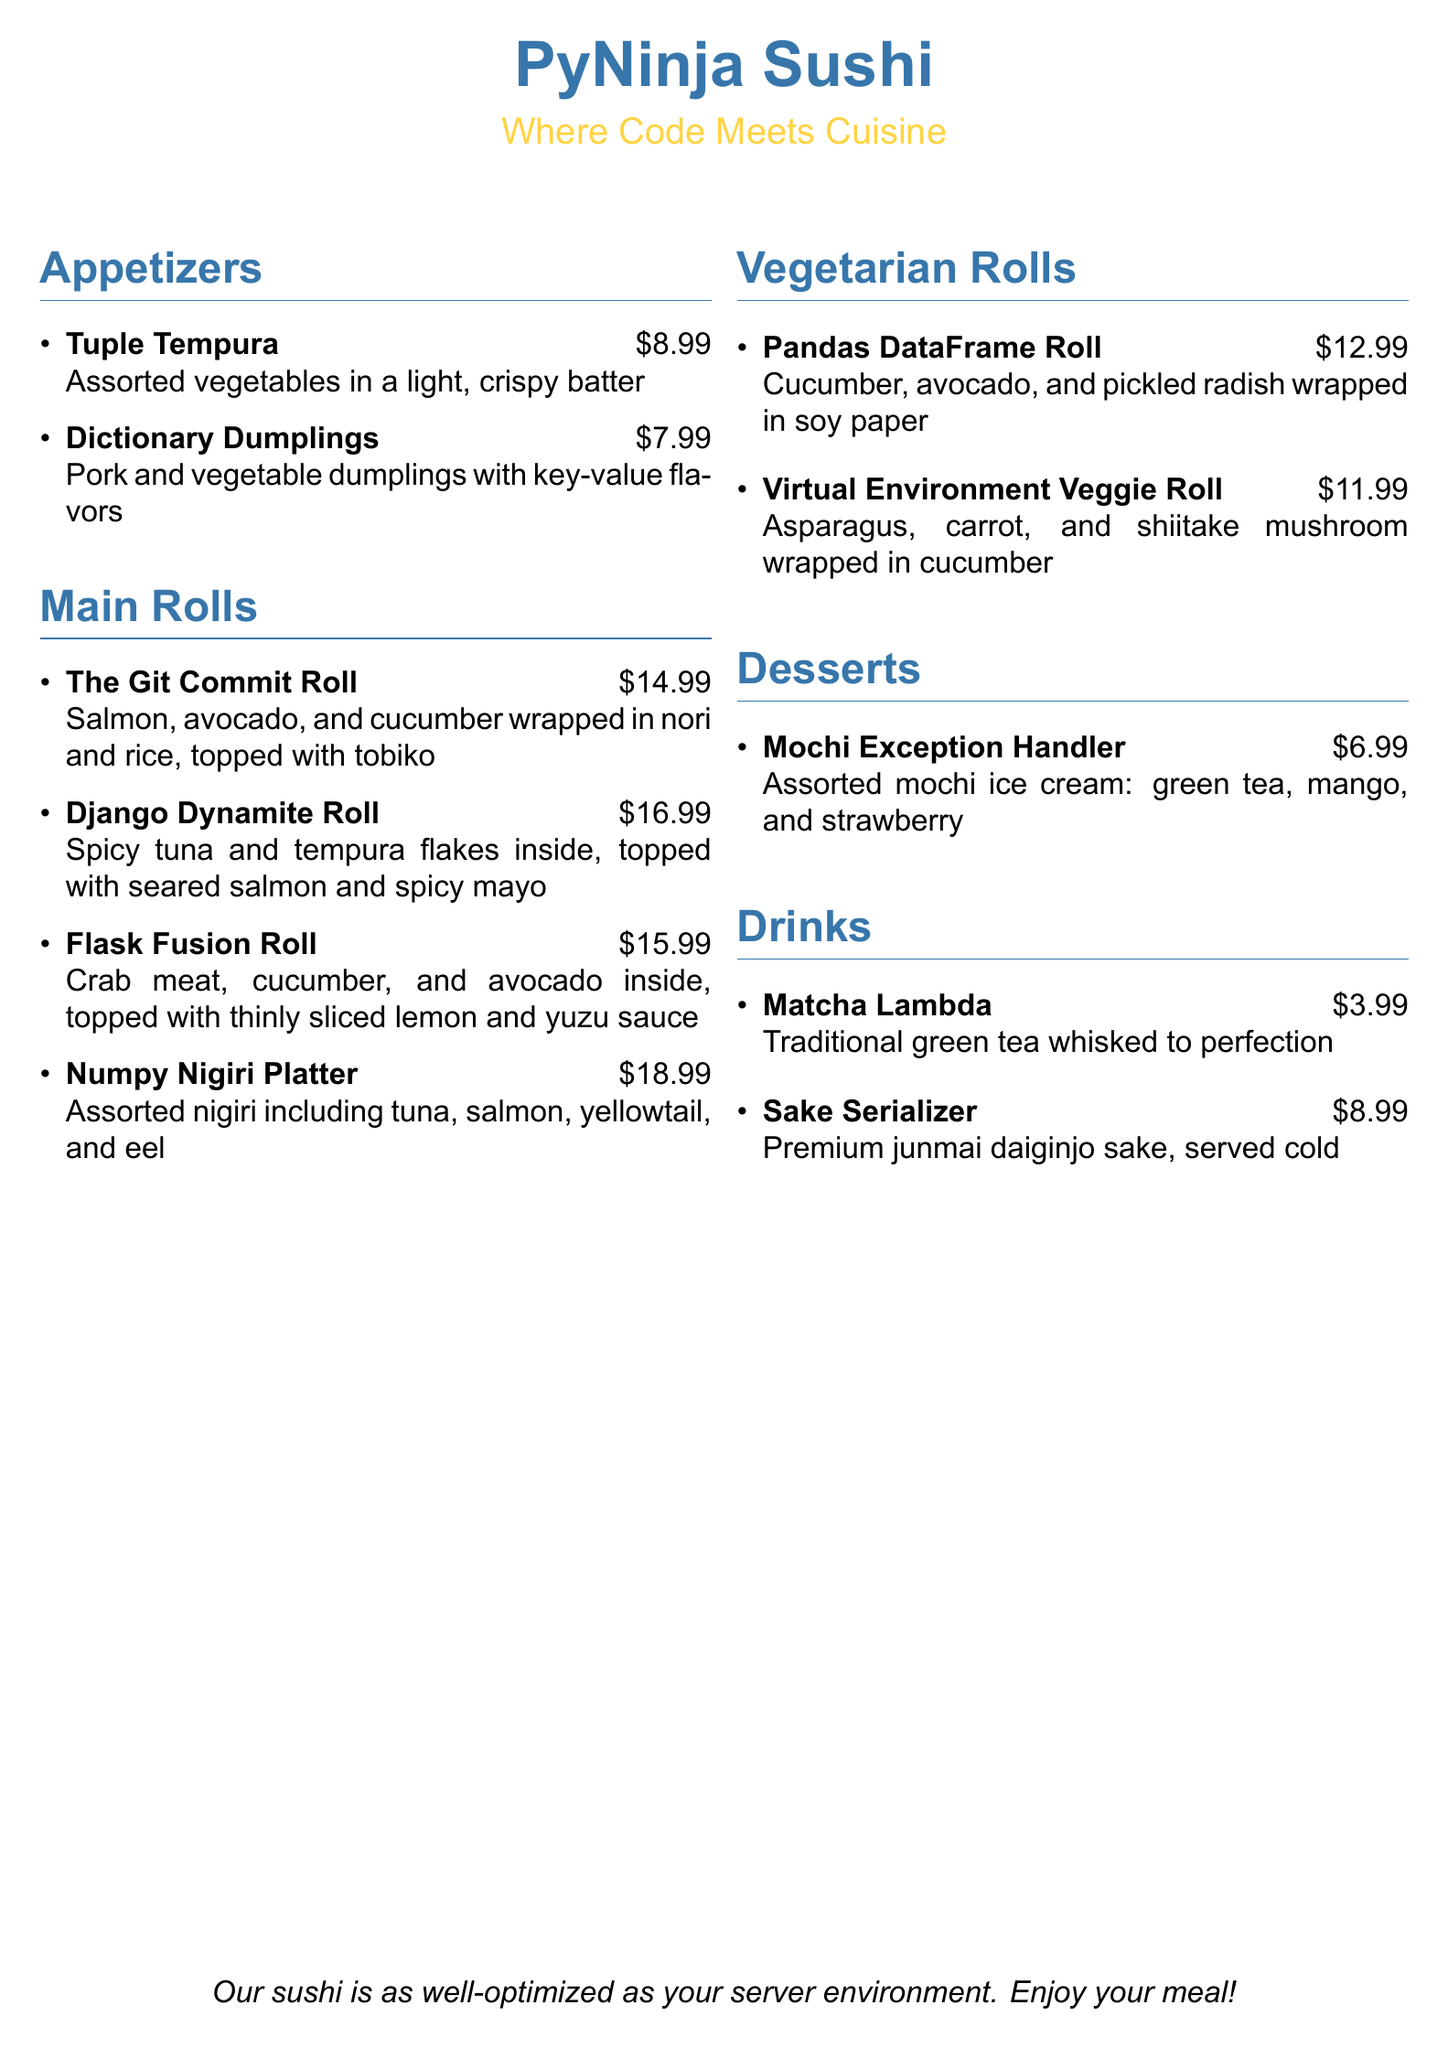What is the name of the restaurant? The restaurant is named "PyNinja Sushi" as displayed prominently at the top of the menu.
Answer: PyNinja Sushi How much does the Dictionary Dumplings cost? The cost of the Dictionary Dumplings is listed next to its name in the appetizers section.
Answer: $7.99 Which roll is topped with seared salmon? The roll that is topped with seared salmon is described in the main rolls section.
Answer: Django Dynamite Roll What ingredients are in the Flask Fusion Roll? The ingredients of the Flask Fusion Roll are mentioned in its description under main rolls.
Answer: Crab meat, cucumber, and avocado What is the price of the Numpy Nigiri Platter? The price of the Numpy Nigiri Platter can be found in the main rolls section alongside its name.
Answer: $18.99 Which drink is served cold? The drink that is served cold is specifically mentioned in the drinks section.
Answer: Sake Serializer How many vegetarian rolls are listed on the menu? The number of vegetarian rolls is determined by counting the items in the vegetarian rolls section.
Answer: 2 What dessert is described as assorted mochi ice cream? The dessert described as assorted mochi ice cream is named in the desserts section.
Answer: Mochi Exception Handler What color is used for the restaurant name? The color for the restaurant name is specified in the formatting options of the document.
Answer: Python blue 